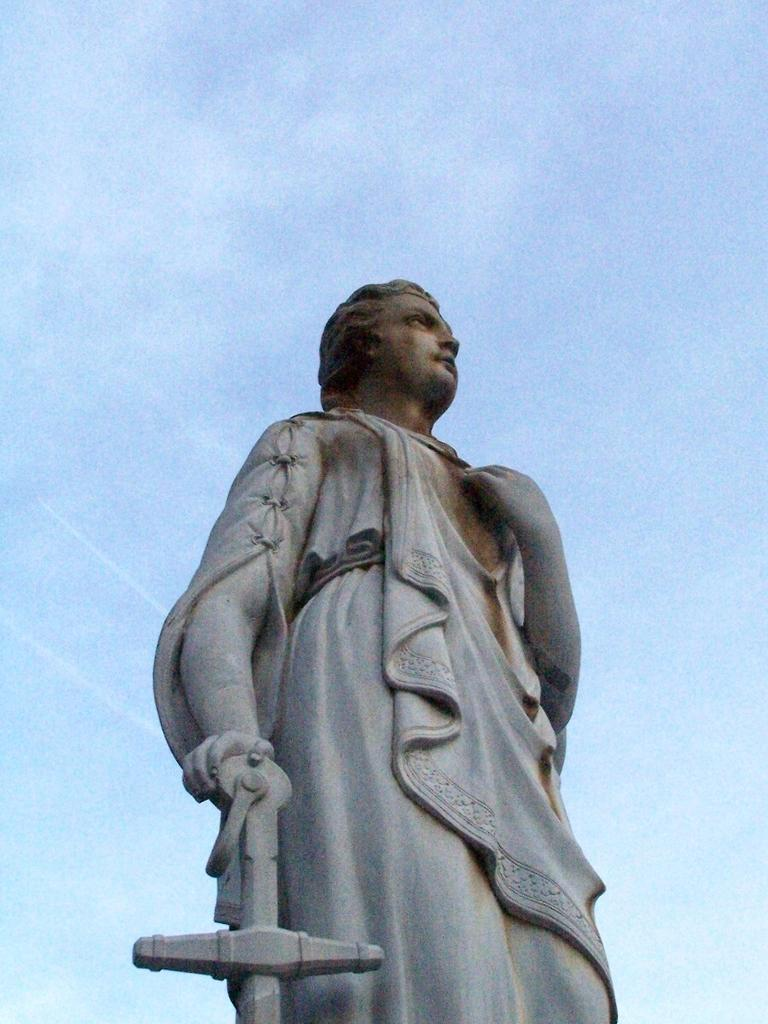What is the main subject in the image? There is a statue in the image. What can be seen in the background of the image? The sky is visible in the image. What grade did the father receive in the image? There is no father or grade present in the image; it only features a statue and the sky. 